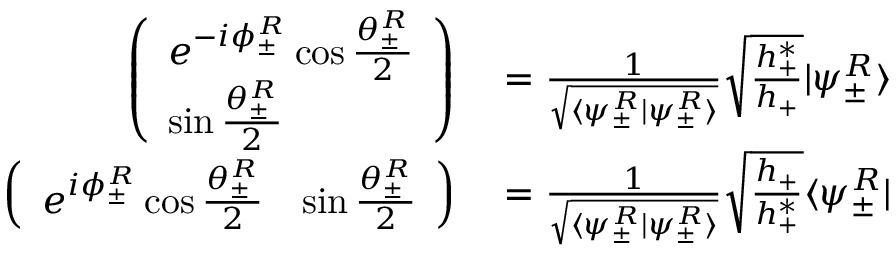Convert formula to latex. <formula><loc_0><loc_0><loc_500><loc_500>\begin{array} { r l } { \left ( \begin{array} { l } { e ^ { - i \phi _ { \pm } ^ { R } } \cos \frac { \theta _ { \pm } ^ { R } } { 2 } } \\ { \sin \frac { \theta _ { \pm } ^ { R } } { 2 } } \end{array} \right ) } & = \frac { 1 } { \sqrt { \langle \psi _ { \pm } ^ { R } | \psi _ { \pm } ^ { R } \rangle } } \sqrt { \frac { h _ { + } ^ { * } } { h _ { + } } } | \psi _ { \pm } ^ { R } \rangle } \\ { \left ( \begin{array} { l l } { e ^ { i \phi _ { \pm } ^ { R } } \cos \frac { \theta _ { \pm } ^ { R } } { 2 } } & { \sin \frac { \theta _ { \pm } ^ { R } } { 2 } } \end{array} \right ) } & = \frac { 1 } { \sqrt { \langle \psi _ { \pm } ^ { R } | \psi _ { \pm } ^ { R } \rangle } } \sqrt { \frac { h _ { + } } { h _ { + } ^ { * } } } \langle \psi _ { \pm } ^ { R } | } \end{array}</formula> 